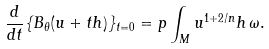Convert formula to latex. <formula><loc_0><loc_0><loc_500><loc_500>\frac { d } { d t } \{ B _ { \theta } ( u + t h ) \} _ { t = 0 } = p \int _ { M } u ^ { 1 + 2 / n } h \, \omega .</formula> 